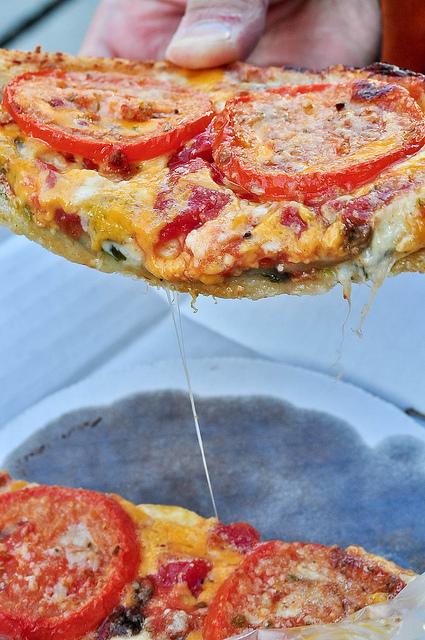What are the round,red things?
Short answer required. Tomatoes. Does the food resemble pizza?
Write a very short answer. Yes. Is this dish cheesy?
Short answer required. Yes. 